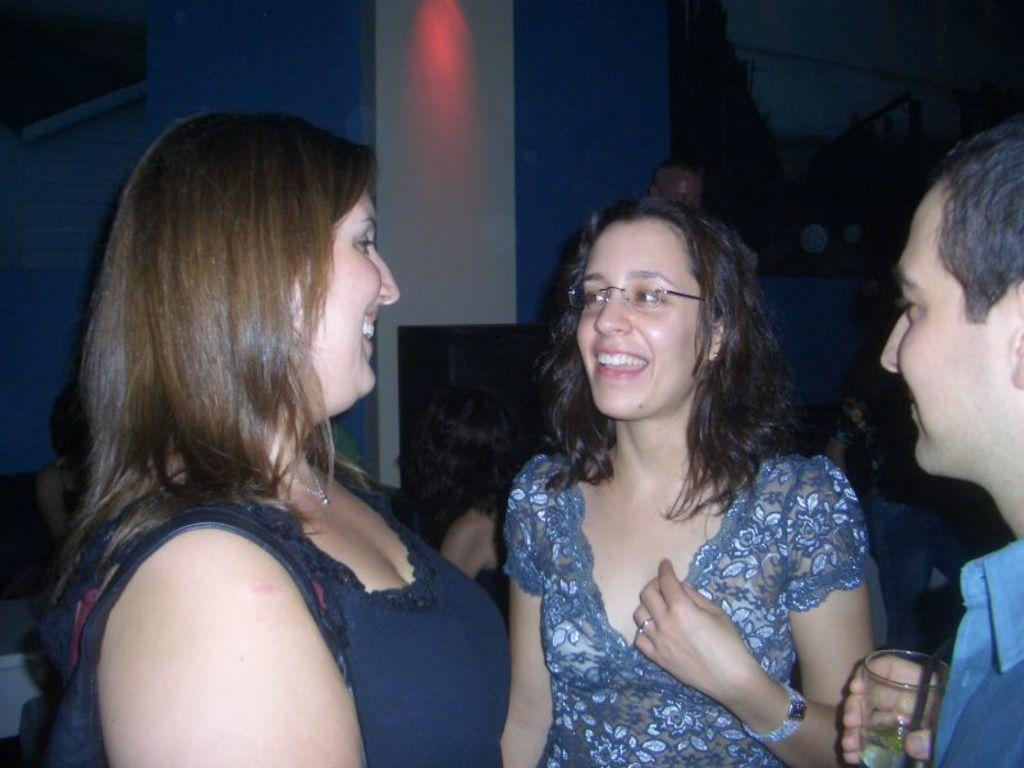What are the people in the image doing? The people in the image are standing and smiling. Can you describe the man on the right side of the image? The man on the right side of the image is standing and holding a glass. What can be seen in the background of the image? In the background of the image, there are people, walls, and light visible. What type of metal is the ground made of in the image? There is no mention of a ground or metal in the image; it primarily features people standing and smiling. 